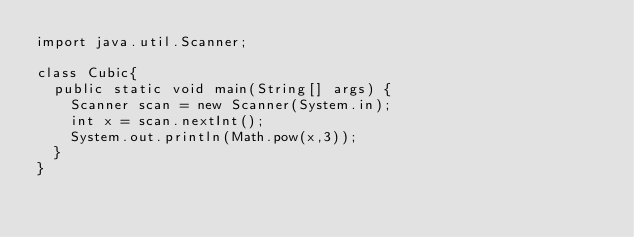<code> <loc_0><loc_0><loc_500><loc_500><_Java_>import java.util.Scanner;

class Cubic{
  public static void main(String[] args) {
    Scanner scan = new Scanner(System.in);
    int x = scan.nextInt();
    System.out.println(Math.pow(x,3));
  }
}</code> 